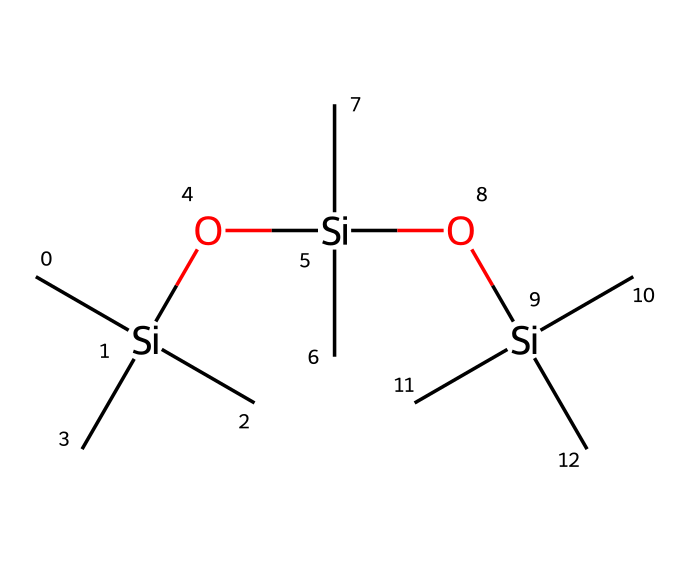What is the primary functional group present in this organosilicon compound? The compound contains silicon atoms and hydroxyl groups (indicated by the "O" connected to Si). The presence of silicon and oxygen suggests that the primary functional group is silanol.
Answer: silanol How many silicon atoms are present in the structure? By examining the SMILES, there are three silicon atoms represented. Each section showing "[Si]" indicates a silicon atom.
Answer: 3 What type of bonds are predominantly present in this organosilicon compound? The structure contains silicon-oxygen bonds, as indicated by the connections between silicon and oxygen ("Si-O"). These bonds are characteristic of organosilicon compounds.
Answer: Si-O What is the total number of carbon atoms in the molecular structure? The SMILES representation shows multiple "[Si](C)(C)" sections, indicating two carbons are connected to each silicon atom. Since there are three silicon atoms, there are a total of six carbon atoms.
Answer: 6 What type of application would benefit from the weather-resistant properties of this compound? Given the structure indicated for coatings with alkyl groups and resistance to environmental factors, this organosilicon compound is suitable for outdoor speakers subjected to weather conditions.
Answer: outdoor speakers What does the presence of multiple carbon atoms imply about the organic nature of this compound? The presence of several carbon atoms attached to silicon suggests a hybrid organosilicon structure that combines properties of silicone and organic compounds, enhancing hydrophobicity and durability.
Answer: hydrophobicity Which feature of this compound aids in its weather resistance? The silicon-oxygen bond (Si-O) and the overall structure, which provides flexibility and stability, contribute to the weather-resistant properties of the coating.
Answer: Si-O bond 